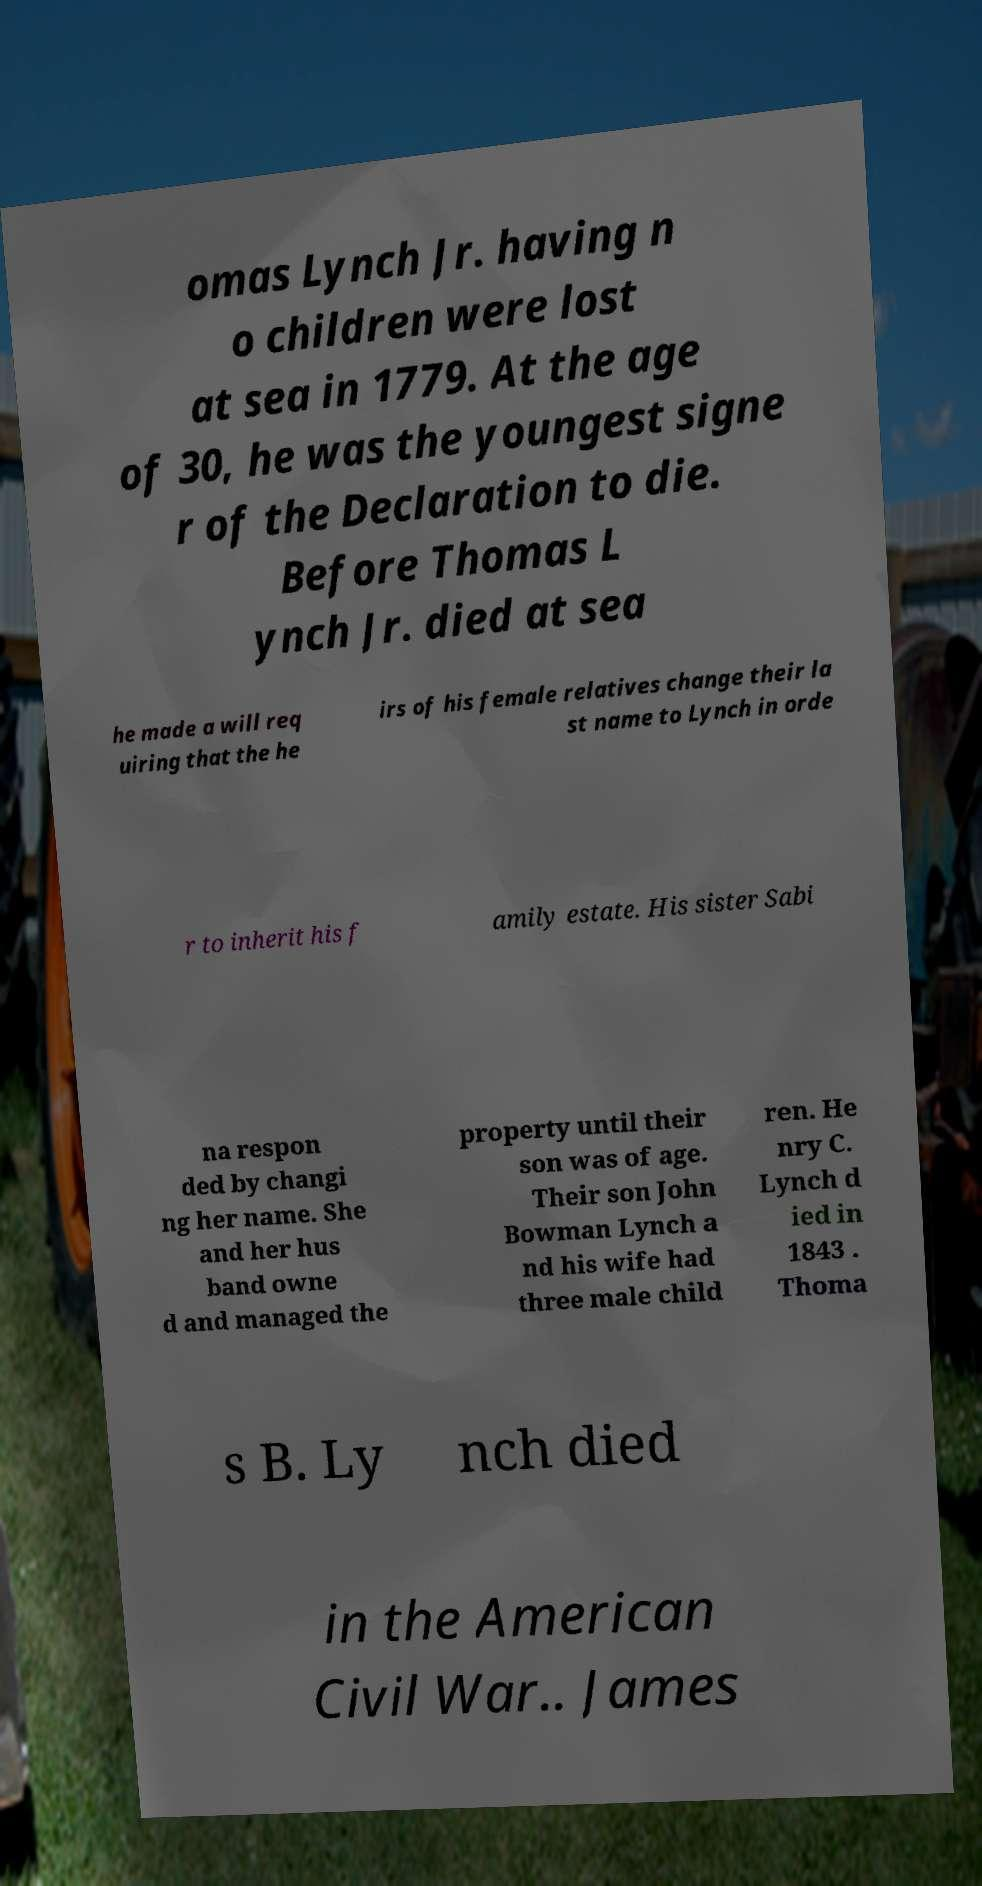What messages or text are displayed in this image? I need them in a readable, typed format. omas Lynch Jr. having n o children were lost at sea in 1779. At the age of 30, he was the youngest signe r of the Declaration to die. Before Thomas L ynch Jr. died at sea he made a will req uiring that the he irs of his female relatives change their la st name to Lynch in orde r to inherit his f amily estate. His sister Sabi na respon ded by changi ng her name. She and her hus band owne d and managed the property until their son was of age. Their son John Bowman Lynch a nd his wife had three male child ren. He nry C. Lynch d ied in 1843 . Thoma s B. Ly nch died in the American Civil War.. James 